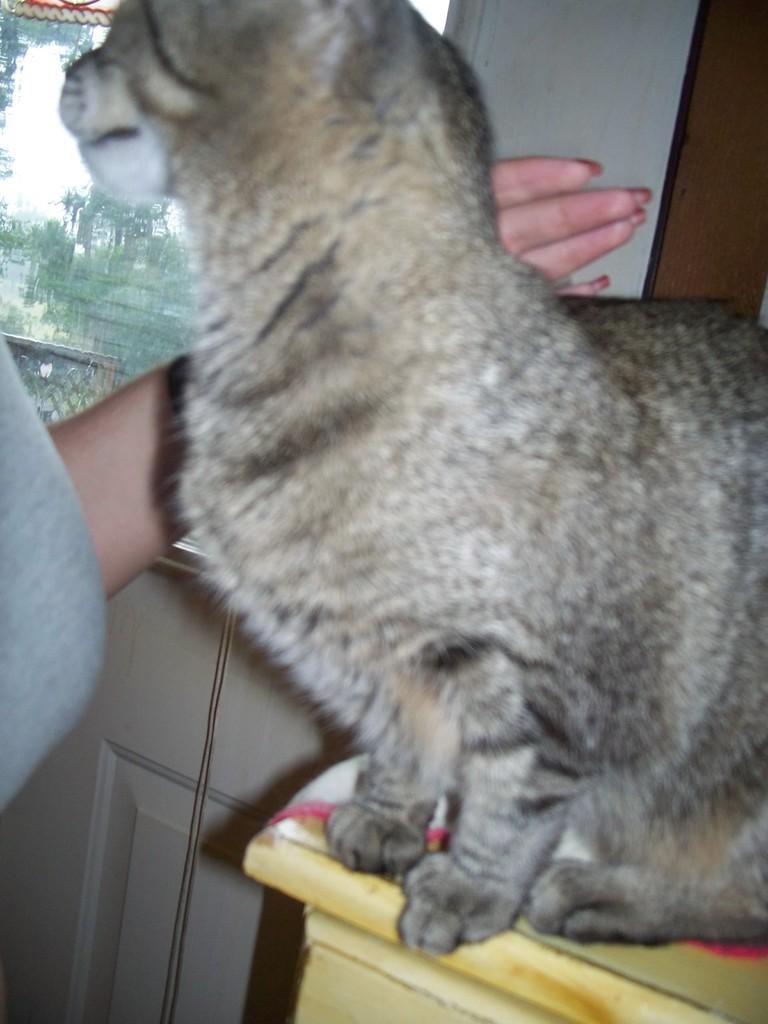What animal is present in the image? There is a cat in the image. What is the cat doing in the image? The cat is sitting on an object. Can you describe the person's hand visible behind the cat? There is a person's hand visible behind the cat. What can be seen in the background of the image? There is a wall and a window in the background of the image. What type of ink is being used by the cat in the image? There is no ink present in the image, and the cat is not using any ink. How does the bell react to the cat's presence in the image? There is no bell present in the image, so it cannot react to the cat's presence. 